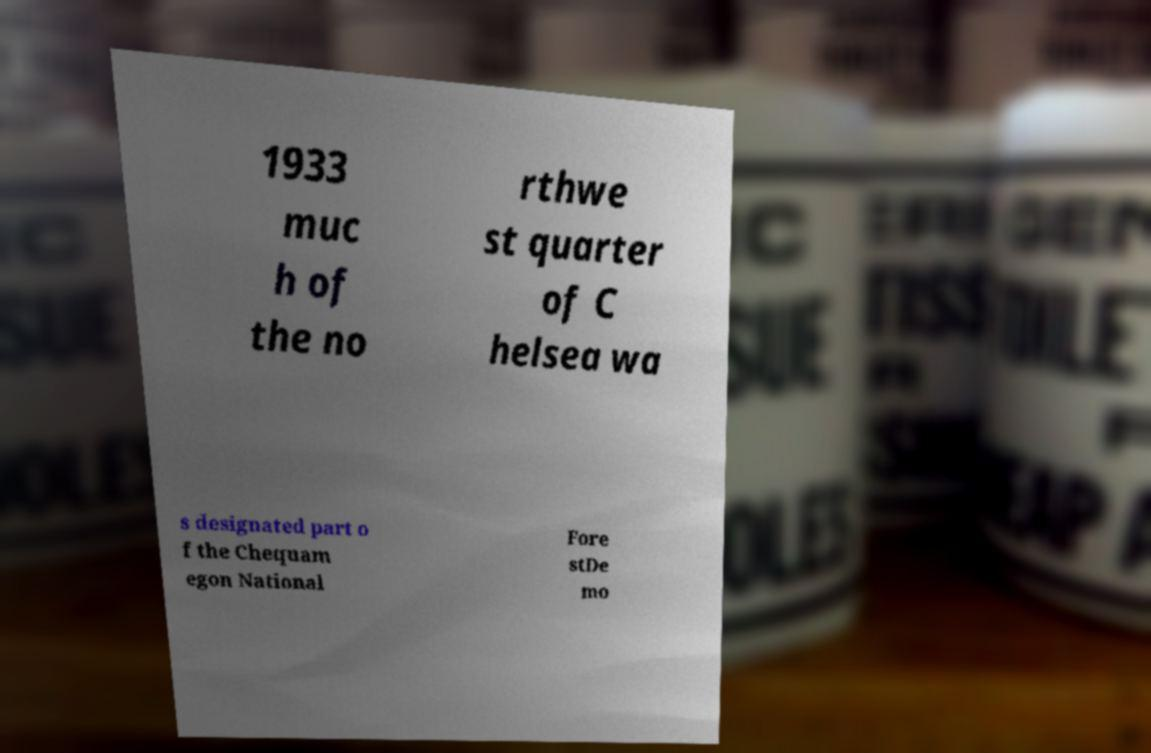Please read and relay the text visible in this image. What does it say? 1933 muc h of the no rthwe st quarter of C helsea wa s designated part o f the Chequam egon National Fore stDe mo 